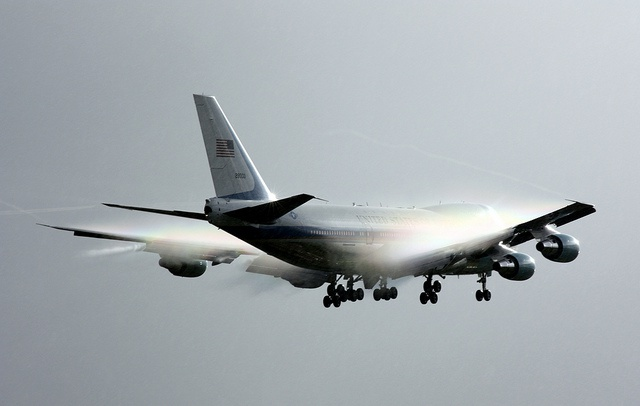Describe the objects in this image and their specific colors. I can see a airplane in darkgray, black, lightgray, and gray tones in this image. 